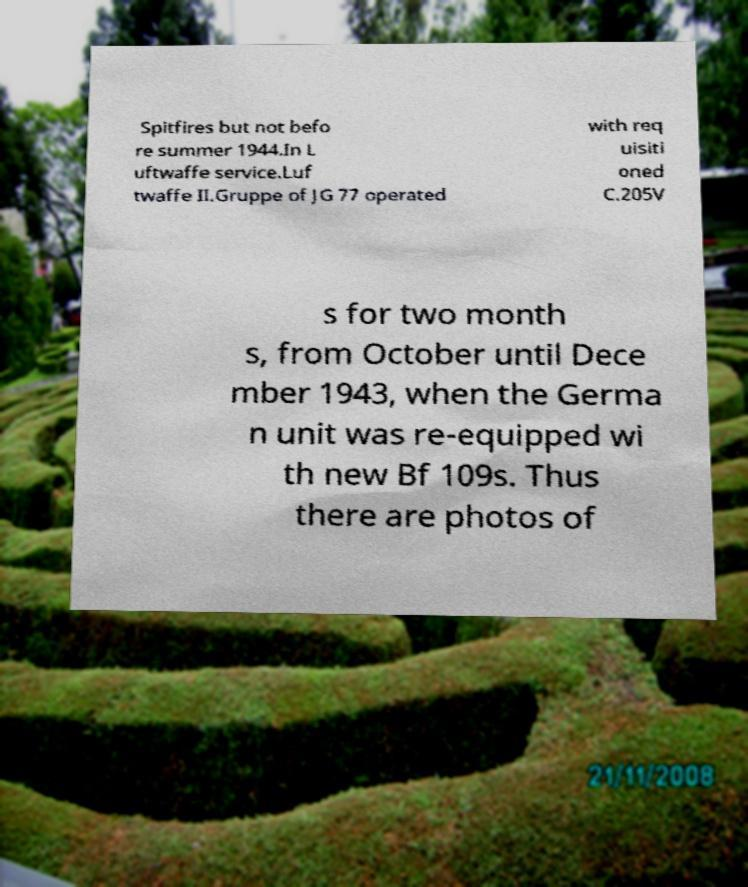For documentation purposes, I need the text within this image transcribed. Could you provide that? Spitfires but not befo re summer 1944.In L uftwaffe service.Luf twaffe II.Gruppe of JG 77 operated with req uisiti oned C.205V s for two month s, from October until Dece mber 1943, when the Germa n unit was re-equipped wi th new Bf 109s. Thus there are photos of 